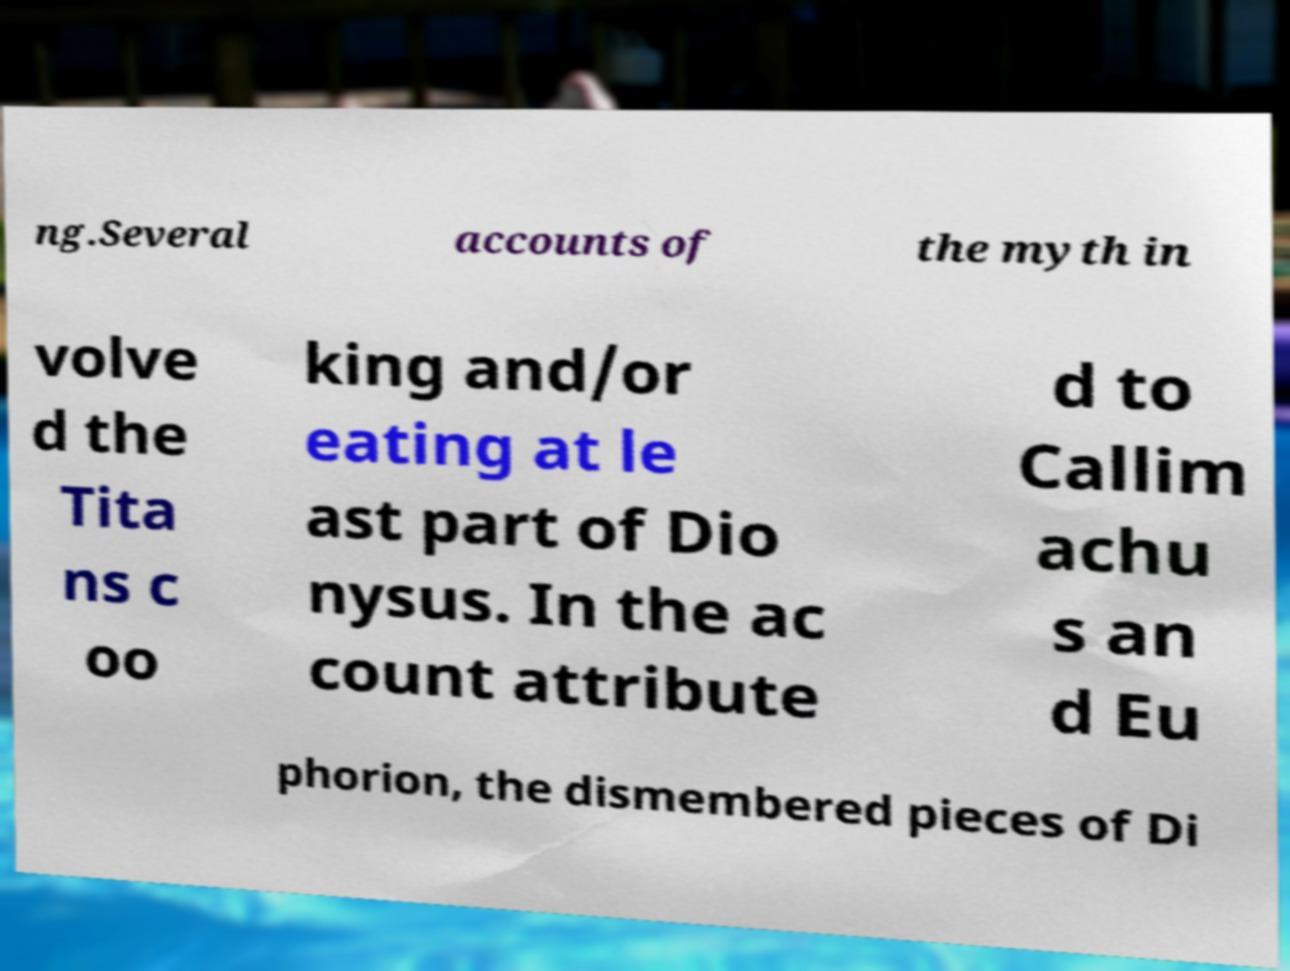Please identify and transcribe the text found in this image. ng.Several accounts of the myth in volve d the Tita ns c oo king and/or eating at le ast part of Dio nysus. In the ac count attribute d to Callim achu s an d Eu phorion, the dismembered pieces of Di 